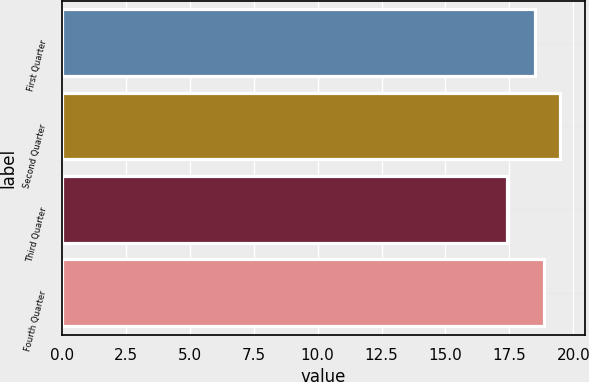Convert chart. <chart><loc_0><loc_0><loc_500><loc_500><bar_chart><fcel>First Quarter<fcel>Second Quarter<fcel>Third Quarter<fcel>Fourth Quarter<nl><fcel>18.5<fcel>19.47<fcel>17.41<fcel>18.85<nl></chart> 